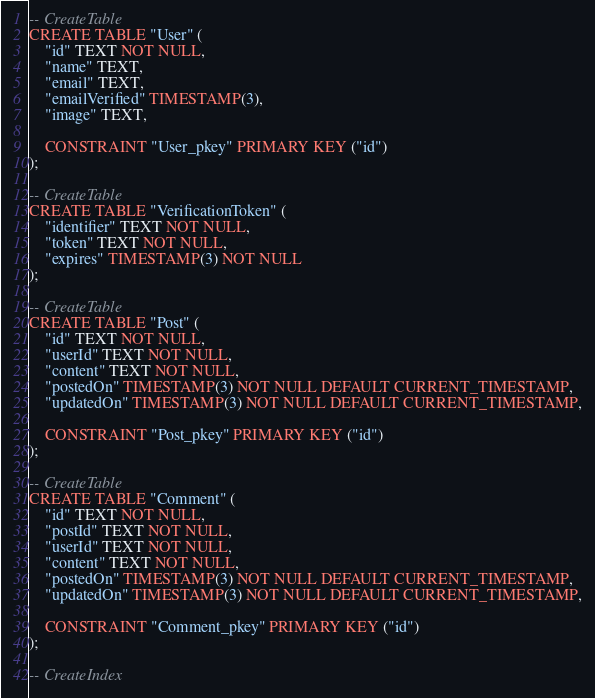Convert code to text. <code><loc_0><loc_0><loc_500><loc_500><_SQL_>-- CreateTable
CREATE TABLE "User" (
    "id" TEXT NOT NULL,
    "name" TEXT,
    "email" TEXT,
    "emailVerified" TIMESTAMP(3),
    "image" TEXT,

    CONSTRAINT "User_pkey" PRIMARY KEY ("id")
);

-- CreateTable
CREATE TABLE "VerificationToken" (
    "identifier" TEXT NOT NULL,
    "token" TEXT NOT NULL,
    "expires" TIMESTAMP(3) NOT NULL
);

-- CreateTable
CREATE TABLE "Post" (
    "id" TEXT NOT NULL,
    "userId" TEXT NOT NULL,
    "content" TEXT NOT NULL,
    "postedOn" TIMESTAMP(3) NOT NULL DEFAULT CURRENT_TIMESTAMP,
    "updatedOn" TIMESTAMP(3) NOT NULL DEFAULT CURRENT_TIMESTAMP,

    CONSTRAINT "Post_pkey" PRIMARY KEY ("id")
);

-- CreateTable
CREATE TABLE "Comment" (
    "id" TEXT NOT NULL,
    "postId" TEXT NOT NULL,
    "userId" TEXT NOT NULL,
    "content" TEXT NOT NULL,
    "postedOn" TIMESTAMP(3) NOT NULL DEFAULT CURRENT_TIMESTAMP,
    "updatedOn" TIMESTAMP(3) NOT NULL DEFAULT CURRENT_TIMESTAMP,

    CONSTRAINT "Comment_pkey" PRIMARY KEY ("id")
);

-- CreateIndex</code> 